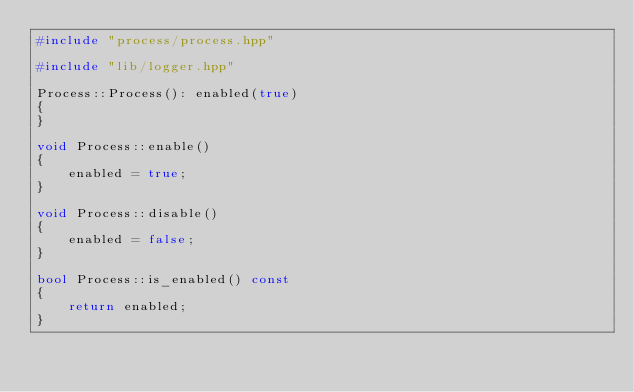Convert code to text. <code><loc_0><loc_0><loc_500><loc_500><_C++_>#include "process/process.hpp"

#include "lib/logger.hpp"

Process::Process(): enabled(true)
{
}

void Process::enable()
{
    enabled = true;
}

void Process::disable()
{
    enabled = false;
}

bool Process::is_enabled() const
{
    return enabled;
}
</code> 